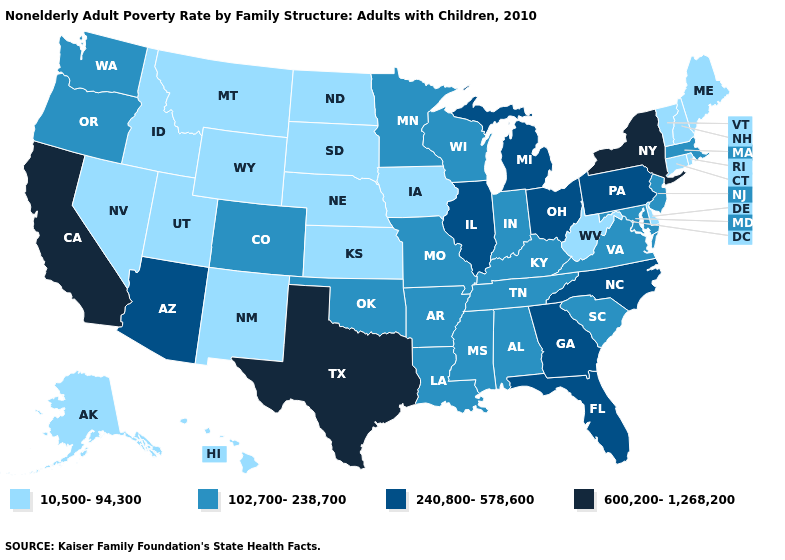Which states have the lowest value in the MidWest?
Write a very short answer. Iowa, Kansas, Nebraska, North Dakota, South Dakota. Among the states that border Kentucky , which have the lowest value?
Keep it brief. West Virginia. What is the highest value in the USA?
Give a very brief answer. 600,200-1,268,200. Name the states that have a value in the range 600,200-1,268,200?
Write a very short answer. California, New York, Texas. Name the states that have a value in the range 240,800-578,600?
Be succinct. Arizona, Florida, Georgia, Illinois, Michigan, North Carolina, Ohio, Pennsylvania. Which states have the lowest value in the USA?
Short answer required. Alaska, Connecticut, Delaware, Hawaii, Idaho, Iowa, Kansas, Maine, Montana, Nebraska, Nevada, New Hampshire, New Mexico, North Dakota, Rhode Island, South Dakota, Utah, Vermont, West Virginia, Wyoming. Which states hav the highest value in the MidWest?
Concise answer only. Illinois, Michigan, Ohio. Which states have the highest value in the USA?
Quick response, please. California, New York, Texas. Name the states that have a value in the range 600,200-1,268,200?
Answer briefly. California, New York, Texas. Does Indiana have the lowest value in the MidWest?
Keep it brief. No. Does Rhode Island have the lowest value in the USA?
Answer briefly. Yes. Does West Virginia have the highest value in the USA?
Short answer required. No. Name the states that have a value in the range 240,800-578,600?
Quick response, please. Arizona, Florida, Georgia, Illinois, Michigan, North Carolina, Ohio, Pennsylvania. Does Louisiana have a higher value than North Carolina?
Answer briefly. No. Among the states that border Arizona , does California have the highest value?
Give a very brief answer. Yes. 